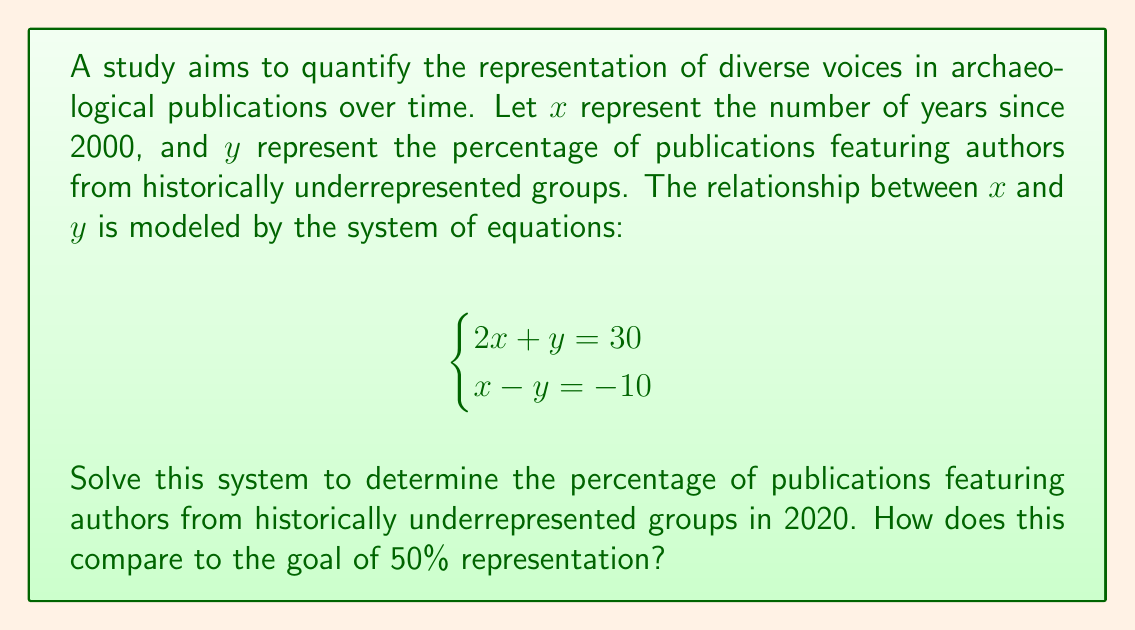Teach me how to tackle this problem. To solve this system of equations, we'll use the substitution method:

1) From the second equation, we can express $y$ in terms of $x$:
   $x - y = -10$
   $y = x + 10$

2) Substitute this expression for $y$ into the first equation:
   $2x + (x + 10) = 30$

3) Simplify:
   $3x + 10 = 30$
   $3x = 20$
   $x = \frac{20}{3} \approx 6.67$

4) Since $x$ represents the number of years since 2000, $x = 20$ corresponds to the year 2020.

5) To find $y$ for 2020, substitute $x = 20$ into the equation from step 1:
   $y = 20 + 10 = 30$

Therefore, in 2020, the model predicts that 30% of publications will feature authors from historically underrepresented groups.

To compare this to the goal of 50% representation:
$50\% - 30\% = 20\%$

The 2020 prediction falls 20 percentage points short of the 50% goal.
Answer: In 2020, the model predicts 30% of publications will feature authors from historically underrepresented groups, which is 20 percentage points below the 50% representation goal. 